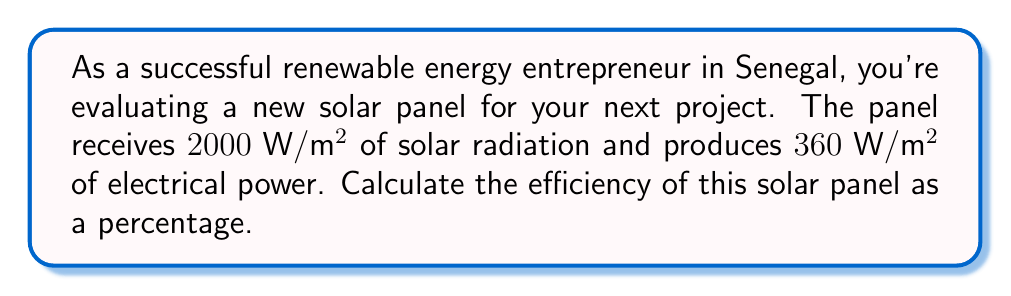What is the answer to this math problem? To calculate the efficiency of a solar panel, we need to determine the ratio of output power to input power and express it as a percentage. Let's follow these steps:

1. Identify the input and output powers:
   Input power (solar radiation) = $2000 \text{ W}/\text{m}^2$
   Output power (electrical) = $360 \text{ W}/\text{m}^2$

2. Calculate the efficiency using the formula:
   $$ \text{Efficiency} = \frac{\text{Output Power}}{\text{Input Power}} \times 100\% $$

3. Substitute the values:
   $$ \text{Efficiency} = \frac{360 \text{ W}/\text{m}^2}{2000 \text{ W}/\text{m}^2} \times 100\% $$

4. Simplify the fraction:
   $$ \text{Efficiency} = \frac{360}{2000} \times 100\% = 0.18 \times 100\% $$

5. Calculate the final percentage:
   $$ \text{Efficiency} = 18\% $$

Therefore, the efficiency of the solar panel is 18%.
Answer: 18% 